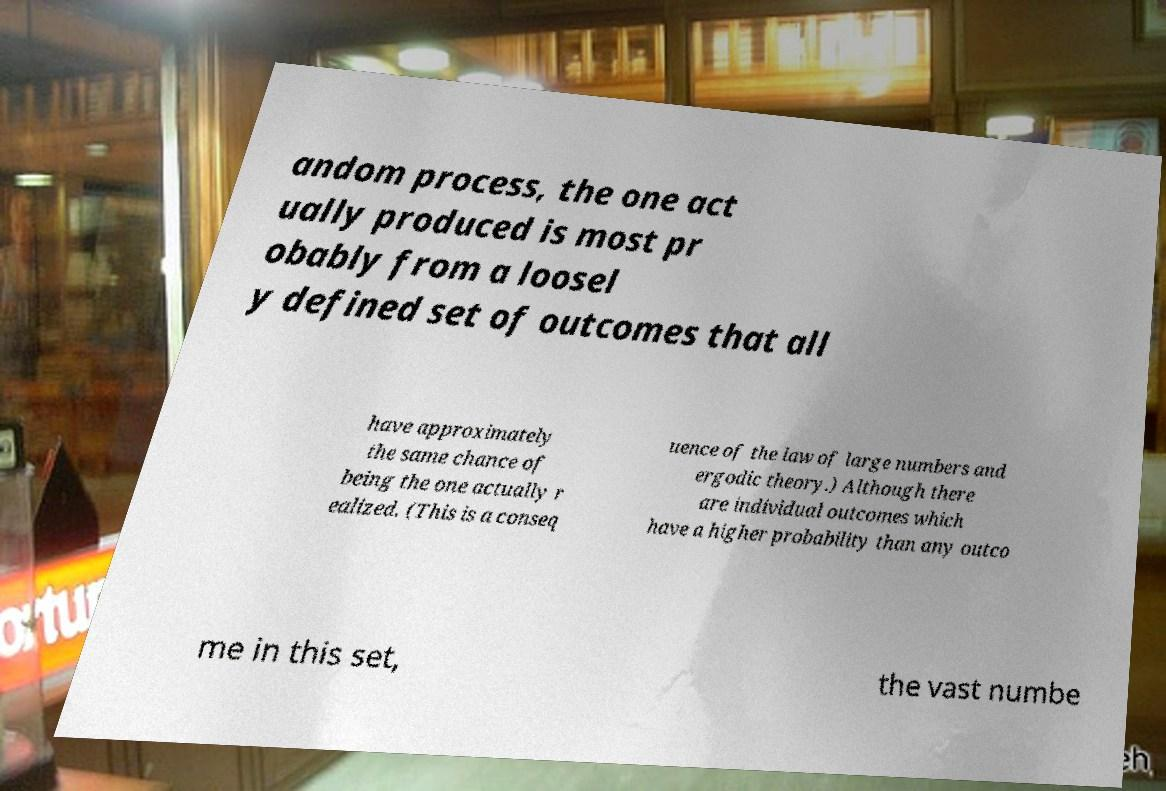Please identify and transcribe the text found in this image. andom process, the one act ually produced is most pr obably from a loosel y defined set of outcomes that all have approximately the same chance of being the one actually r ealized. (This is a conseq uence of the law of large numbers and ergodic theory.) Although there are individual outcomes which have a higher probability than any outco me in this set, the vast numbe 